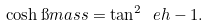<formula> <loc_0><loc_0><loc_500><loc_500>\cosh \i m a s s = { \tan ^ { 2 } } \ e h - 1 .</formula> 